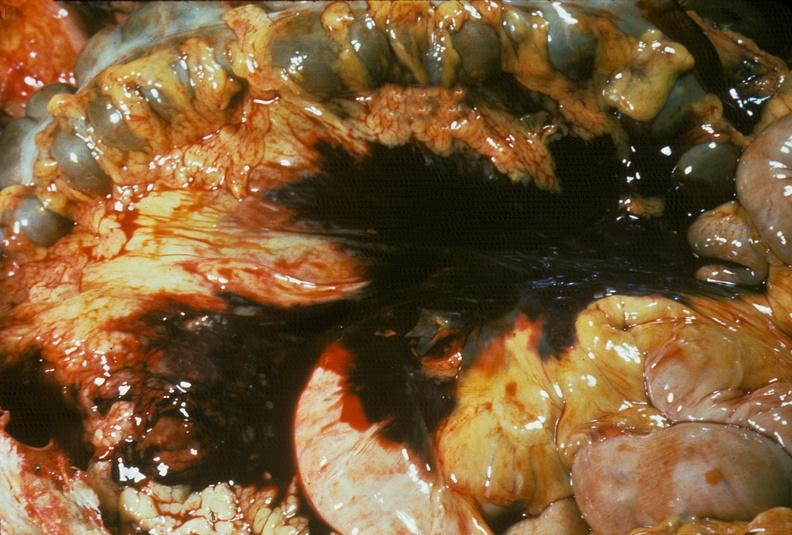where is this area in the body?
Answer the question using a single word or phrase. Abdomen 